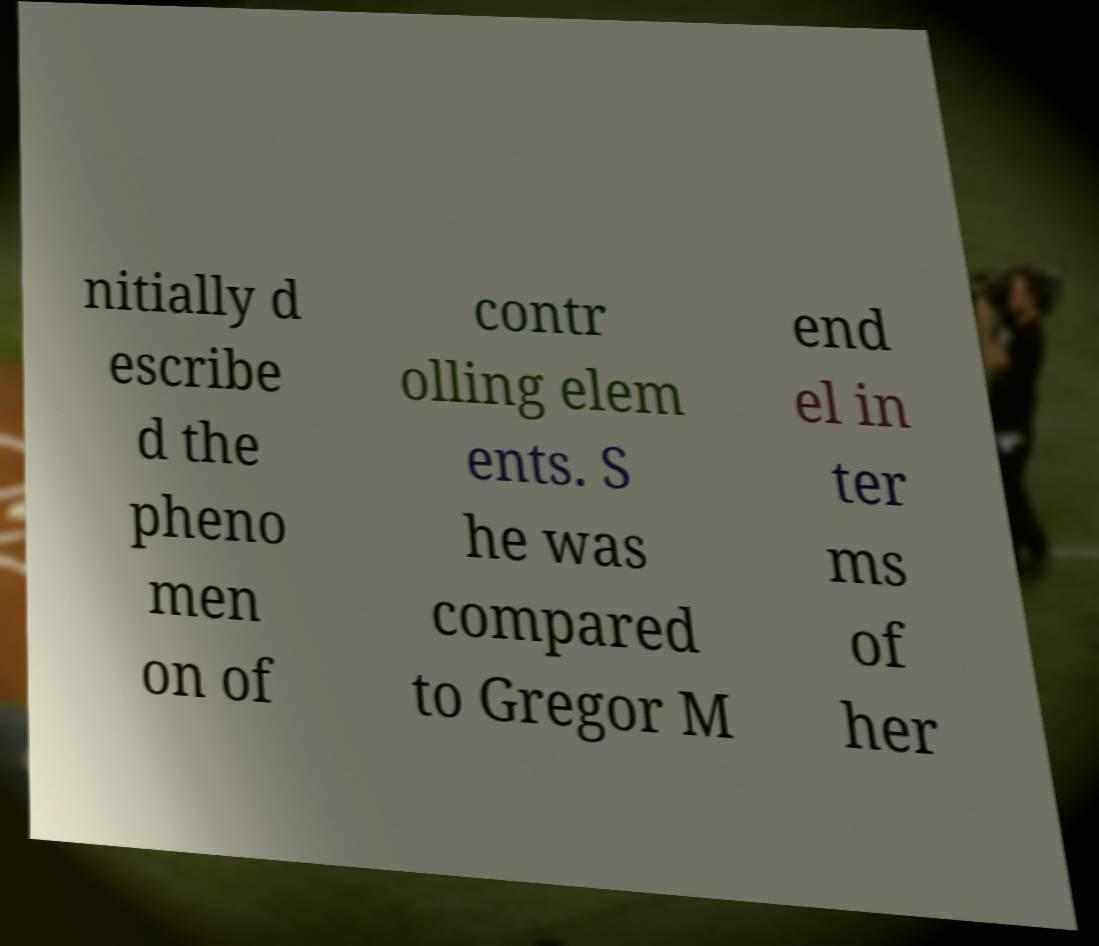Can you read and provide the text displayed in the image?This photo seems to have some interesting text. Can you extract and type it out for me? nitially d escribe d the pheno men on of contr olling elem ents. S he was compared to Gregor M end el in ter ms of her 